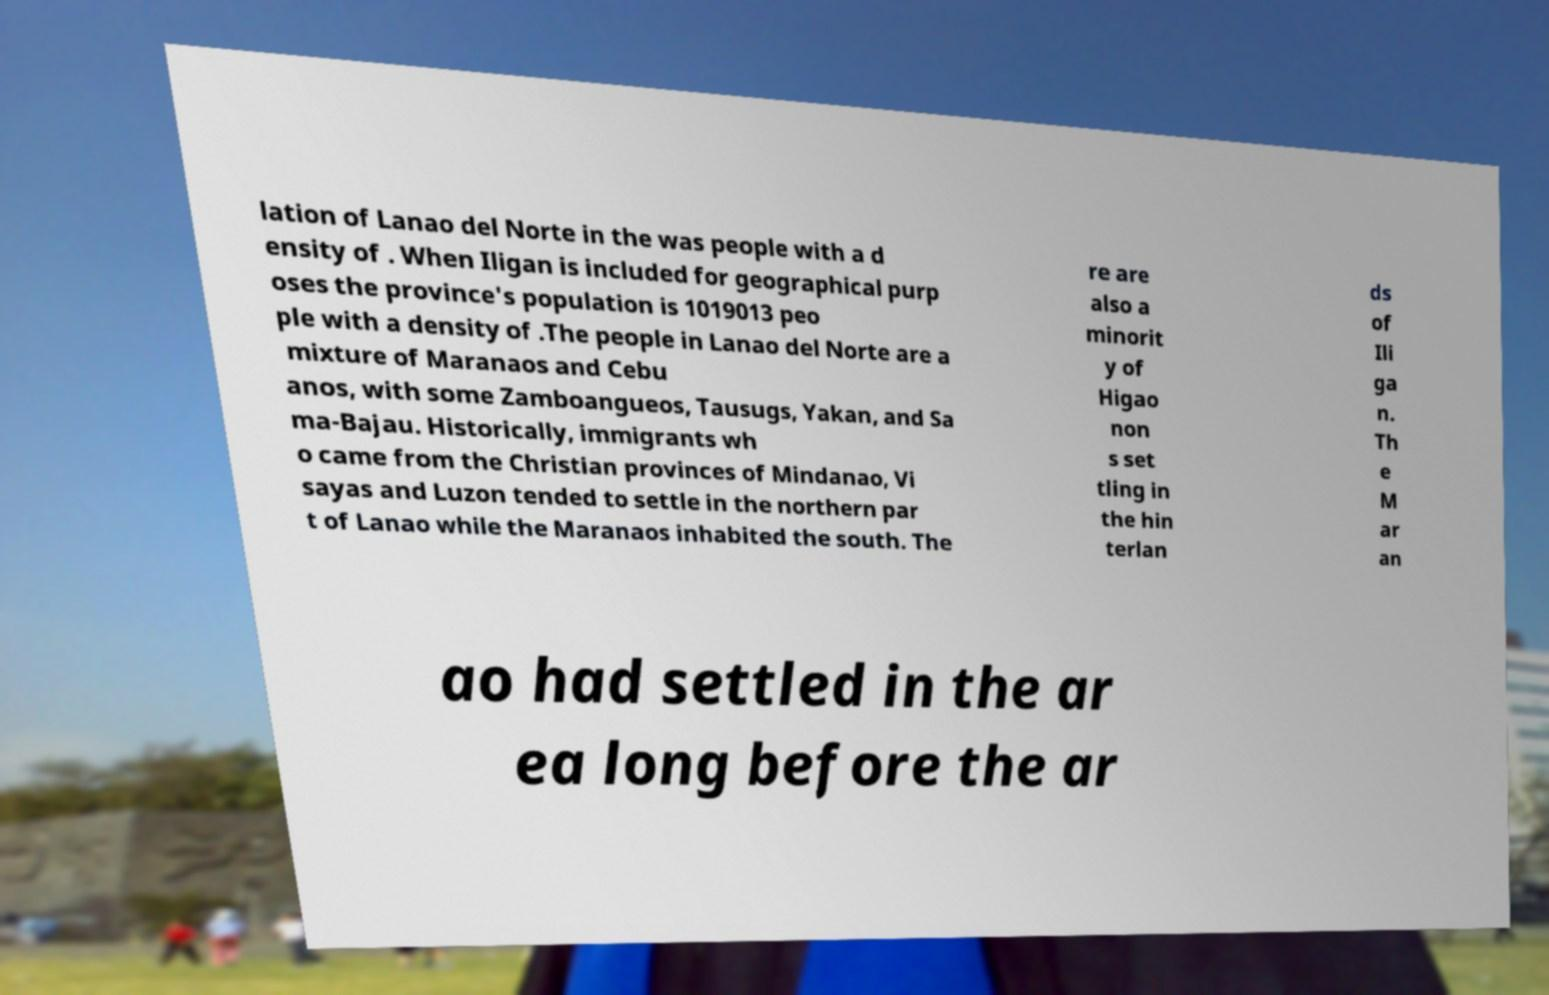Can you accurately transcribe the text from the provided image for me? lation of Lanao del Norte in the was people with a d ensity of . When Iligan is included for geographical purp oses the province's population is 1019013 peo ple with a density of .The people in Lanao del Norte are a mixture of Maranaos and Cebu anos, with some Zamboangueos, Tausugs, Yakan, and Sa ma-Bajau. Historically, immigrants wh o came from the Christian provinces of Mindanao, Vi sayas and Luzon tended to settle in the northern par t of Lanao while the Maranaos inhabited the south. The re are also a minorit y of Higao non s set tling in the hin terlan ds of Ili ga n. Th e M ar an ao had settled in the ar ea long before the ar 